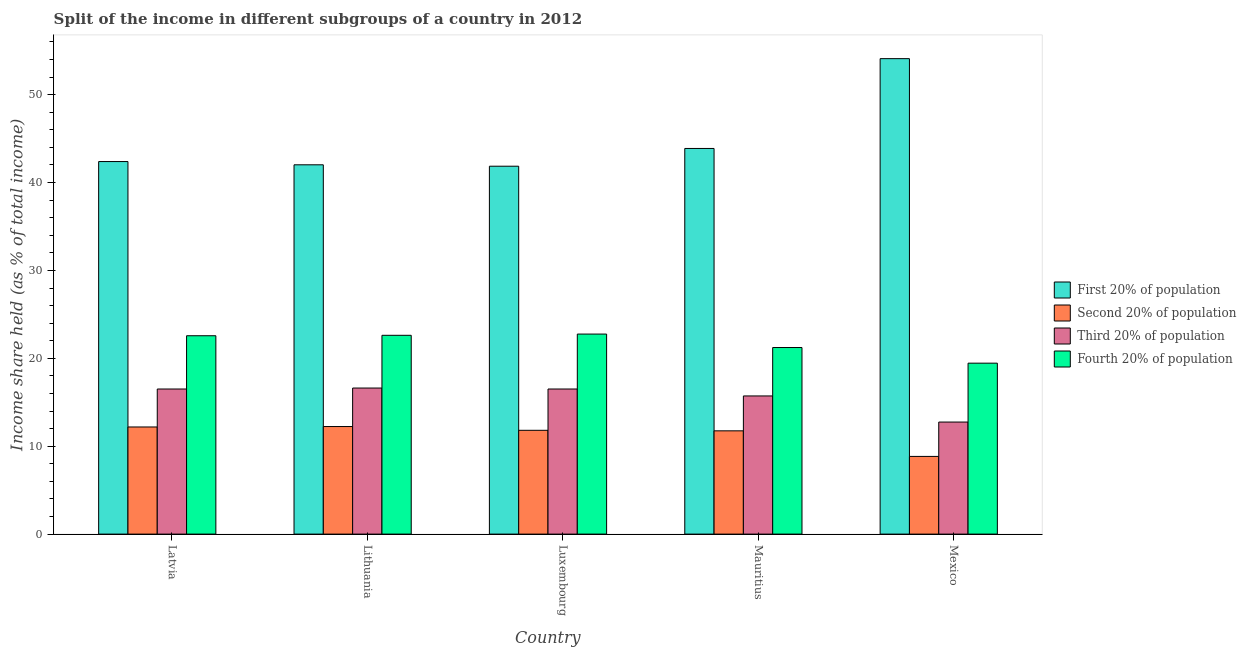How many groups of bars are there?
Ensure brevity in your answer.  5. Are the number of bars per tick equal to the number of legend labels?
Keep it short and to the point. Yes. What is the label of the 1st group of bars from the left?
Keep it short and to the point. Latvia. In how many cases, is the number of bars for a given country not equal to the number of legend labels?
Offer a very short reply. 0. What is the share of the income held by third 20% of the population in Latvia?
Keep it short and to the point. 16.51. Across all countries, what is the maximum share of the income held by third 20% of the population?
Your answer should be compact. 16.62. Across all countries, what is the minimum share of the income held by first 20% of the population?
Your answer should be very brief. 41.86. In which country was the share of the income held by third 20% of the population maximum?
Keep it short and to the point. Lithuania. In which country was the share of the income held by first 20% of the population minimum?
Provide a succinct answer. Luxembourg. What is the total share of the income held by fourth 20% of the population in the graph?
Offer a terse response. 108.63. What is the difference between the share of the income held by third 20% of the population in Mauritius and that in Mexico?
Give a very brief answer. 2.97. What is the difference between the share of the income held by first 20% of the population in Mexico and the share of the income held by second 20% of the population in Mauritius?
Ensure brevity in your answer.  42.35. What is the average share of the income held by fourth 20% of the population per country?
Ensure brevity in your answer.  21.73. What is the difference between the share of the income held by fourth 20% of the population and share of the income held by first 20% of the population in Mexico?
Your answer should be compact. -34.65. What is the ratio of the share of the income held by third 20% of the population in Lithuania to that in Luxembourg?
Ensure brevity in your answer.  1.01. Is the share of the income held by second 20% of the population in Latvia less than that in Mauritius?
Provide a short and direct response. No. What is the difference between the highest and the second highest share of the income held by third 20% of the population?
Your response must be concise. 0.11. What is the difference between the highest and the lowest share of the income held by third 20% of the population?
Provide a short and direct response. 3.87. Is the sum of the share of the income held by third 20% of the population in Mauritius and Mexico greater than the maximum share of the income held by fourth 20% of the population across all countries?
Offer a terse response. Yes. What does the 1st bar from the left in Mexico represents?
Provide a succinct answer. First 20% of population. What does the 4th bar from the right in Mexico represents?
Keep it short and to the point. First 20% of population. Is it the case that in every country, the sum of the share of the income held by first 20% of the population and share of the income held by second 20% of the population is greater than the share of the income held by third 20% of the population?
Ensure brevity in your answer.  Yes. How many countries are there in the graph?
Provide a short and direct response. 5. How many legend labels are there?
Provide a succinct answer. 4. What is the title of the graph?
Give a very brief answer. Split of the income in different subgroups of a country in 2012. Does "Other greenhouse gases" appear as one of the legend labels in the graph?
Make the answer very short. No. What is the label or title of the X-axis?
Offer a very short reply. Country. What is the label or title of the Y-axis?
Provide a succinct answer. Income share held (as % of total income). What is the Income share held (as % of total income) of First 20% of population in Latvia?
Offer a very short reply. 42.39. What is the Income share held (as % of total income) in Second 20% of population in Latvia?
Keep it short and to the point. 12.19. What is the Income share held (as % of total income) of Third 20% of population in Latvia?
Keep it short and to the point. 16.51. What is the Income share held (as % of total income) in Fourth 20% of population in Latvia?
Give a very brief answer. 22.57. What is the Income share held (as % of total income) of First 20% of population in Lithuania?
Your answer should be very brief. 42.02. What is the Income share held (as % of total income) in Second 20% of population in Lithuania?
Offer a terse response. 12.24. What is the Income share held (as % of total income) of Third 20% of population in Lithuania?
Provide a short and direct response. 16.62. What is the Income share held (as % of total income) of Fourth 20% of population in Lithuania?
Provide a short and direct response. 22.62. What is the Income share held (as % of total income) of First 20% of population in Luxembourg?
Offer a very short reply. 41.86. What is the Income share held (as % of total income) in Second 20% of population in Luxembourg?
Give a very brief answer. 11.81. What is the Income share held (as % of total income) of Third 20% of population in Luxembourg?
Your answer should be very brief. 16.51. What is the Income share held (as % of total income) of Fourth 20% of population in Luxembourg?
Ensure brevity in your answer.  22.76. What is the Income share held (as % of total income) in First 20% of population in Mauritius?
Ensure brevity in your answer.  43.88. What is the Income share held (as % of total income) of Second 20% of population in Mauritius?
Make the answer very short. 11.75. What is the Income share held (as % of total income) in Third 20% of population in Mauritius?
Keep it short and to the point. 15.72. What is the Income share held (as % of total income) of Fourth 20% of population in Mauritius?
Your answer should be compact. 21.23. What is the Income share held (as % of total income) of First 20% of population in Mexico?
Make the answer very short. 54.1. What is the Income share held (as % of total income) in Second 20% of population in Mexico?
Your answer should be compact. 8.84. What is the Income share held (as % of total income) in Third 20% of population in Mexico?
Ensure brevity in your answer.  12.75. What is the Income share held (as % of total income) in Fourth 20% of population in Mexico?
Offer a terse response. 19.45. Across all countries, what is the maximum Income share held (as % of total income) in First 20% of population?
Make the answer very short. 54.1. Across all countries, what is the maximum Income share held (as % of total income) in Second 20% of population?
Give a very brief answer. 12.24. Across all countries, what is the maximum Income share held (as % of total income) in Third 20% of population?
Provide a succinct answer. 16.62. Across all countries, what is the maximum Income share held (as % of total income) in Fourth 20% of population?
Provide a short and direct response. 22.76. Across all countries, what is the minimum Income share held (as % of total income) of First 20% of population?
Keep it short and to the point. 41.86. Across all countries, what is the minimum Income share held (as % of total income) in Second 20% of population?
Keep it short and to the point. 8.84. Across all countries, what is the minimum Income share held (as % of total income) of Third 20% of population?
Make the answer very short. 12.75. Across all countries, what is the minimum Income share held (as % of total income) in Fourth 20% of population?
Make the answer very short. 19.45. What is the total Income share held (as % of total income) in First 20% of population in the graph?
Keep it short and to the point. 224.25. What is the total Income share held (as % of total income) of Second 20% of population in the graph?
Offer a very short reply. 56.83. What is the total Income share held (as % of total income) of Third 20% of population in the graph?
Provide a short and direct response. 78.11. What is the total Income share held (as % of total income) in Fourth 20% of population in the graph?
Provide a succinct answer. 108.63. What is the difference between the Income share held (as % of total income) of First 20% of population in Latvia and that in Lithuania?
Offer a terse response. 0.37. What is the difference between the Income share held (as % of total income) of Third 20% of population in Latvia and that in Lithuania?
Offer a very short reply. -0.11. What is the difference between the Income share held (as % of total income) of First 20% of population in Latvia and that in Luxembourg?
Provide a succinct answer. 0.53. What is the difference between the Income share held (as % of total income) in Second 20% of population in Latvia and that in Luxembourg?
Your answer should be compact. 0.38. What is the difference between the Income share held (as % of total income) of Third 20% of population in Latvia and that in Luxembourg?
Ensure brevity in your answer.  0. What is the difference between the Income share held (as % of total income) in Fourth 20% of population in Latvia and that in Luxembourg?
Ensure brevity in your answer.  -0.19. What is the difference between the Income share held (as % of total income) in First 20% of population in Latvia and that in Mauritius?
Your answer should be compact. -1.49. What is the difference between the Income share held (as % of total income) in Second 20% of population in Latvia and that in Mauritius?
Give a very brief answer. 0.44. What is the difference between the Income share held (as % of total income) in Third 20% of population in Latvia and that in Mauritius?
Offer a very short reply. 0.79. What is the difference between the Income share held (as % of total income) of Fourth 20% of population in Latvia and that in Mauritius?
Your answer should be very brief. 1.34. What is the difference between the Income share held (as % of total income) in First 20% of population in Latvia and that in Mexico?
Your answer should be very brief. -11.71. What is the difference between the Income share held (as % of total income) in Second 20% of population in Latvia and that in Mexico?
Keep it short and to the point. 3.35. What is the difference between the Income share held (as % of total income) in Third 20% of population in Latvia and that in Mexico?
Ensure brevity in your answer.  3.76. What is the difference between the Income share held (as % of total income) of Fourth 20% of population in Latvia and that in Mexico?
Offer a terse response. 3.12. What is the difference between the Income share held (as % of total income) in First 20% of population in Lithuania and that in Luxembourg?
Your answer should be compact. 0.16. What is the difference between the Income share held (as % of total income) in Second 20% of population in Lithuania and that in Luxembourg?
Keep it short and to the point. 0.43. What is the difference between the Income share held (as % of total income) of Third 20% of population in Lithuania and that in Luxembourg?
Your response must be concise. 0.11. What is the difference between the Income share held (as % of total income) of Fourth 20% of population in Lithuania and that in Luxembourg?
Your response must be concise. -0.14. What is the difference between the Income share held (as % of total income) of First 20% of population in Lithuania and that in Mauritius?
Your response must be concise. -1.86. What is the difference between the Income share held (as % of total income) of Second 20% of population in Lithuania and that in Mauritius?
Ensure brevity in your answer.  0.49. What is the difference between the Income share held (as % of total income) in Fourth 20% of population in Lithuania and that in Mauritius?
Your answer should be very brief. 1.39. What is the difference between the Income share held (as % of total income) in First 20% of population in Lithuania and that in Mexico?
Provide a short and direct response. -12.08. What is the difference between the Income share held (as % of total income) of Third 20% of population in Lithuania and that in Mexico?
Your response must be concise. 3.87. What is the difference between the Income share held (as % of total income) of Fourth 20% of population in Lithuania and that in Mexico?
Your answer should be very brief. 3.17. What is the difference between the Income share held (as % of total income) in First 20% of population in Luxembourg and that in Mauritius?
Offer a terse response. -2.02. What is the difference between the Income share held (as % of total income) of Second 20% of population in Luxembourg and that in Mauritius?
Provide a short and direct response. 0.06. What is the difference between the Income share held (as % of total income) in Third 20% of population in Luxembourg and that in Mauritius?
Make the answer very short. 0.79. What is the difference between the Income share held (as % of total income) in Fourth 20% of population in Luxembourg and that in Mauritius?
Offer a very short reply. 1.53. What is the difference between the Income share held (as % of total income) of First 20% of population in Luxembourg and that in Mexico?
Provide a short and direct response. -12.24. What is the difference between the Income share held (as % of total income) in Second 20% of population in Luxembourg and that in Mexico?
Give a very brief answer. 2.97. What is the difference between the Income share held (as % of total income) of Third 20% of population in Luxembourg and that in Mexico?
Your answer should be compact. 3.76. What is the difference between the Income share held (as % of total income) of Fourth 20% of population in Luxembourg and that in Mexico?
Your response must be concise. 3.31. What is the difference between the Income share held (as % of total income) in First 20% of population in Mauritius and that in Mexico?
Provide a succinct answer. -10.22. What is the difference between the Income share held (as % of total income) of Second 20% of population in Mauritius and that in Mexico?
Offer a very short reply. 2.91. What is the difference between the Income share held (as % of total income) in Third 20% of population in Mauritius and that in Mexico?
Provide a succinct answer. 2.97. What is the difference between the Income share held (as % of total income) of Fourth 20% of population in Mauritius and that in Mexico?
Ensure brevity in your answer.  1.78. What is the difference between the Income share held (as % of total income) of First 20% of population in Latvia and the Income share held (as % of total income) of Second 20% of population in Lithuania?
Provide a short and direct response. 30.15. What is the difference between the Income share held (as % of total income) of First 20% of population in Latvia and the Income share held (as % of total income) of Third 20% of population in Lithuania?
Make the answer very short. 25.77. What is the difference between the Income share held (as % of total income) in First 20% of population in Latvia and the Income share held (as % of total income) in Fourth 20% of population in Lithuania?
Give a very brief answer. 19.77. What is the difference between the Income share held (as % of total income) of Second 20% of population in Latvia and the Income share held (as % of total income) of Third 20% of population in Lithuania?
Give a very brief answer. -4.43. What is the difference between the Income share held (as % of total income) of Second 20% of population in Latvia and the Income share held (as % of total income) of Fourth 20% of population in Lithuania?
Give a very brief answer. -10.43. What is the difference between the Income share held (as % of total income) of Third 20% of population in Latvia and the Income share held (as % of total income) of Fourth 20% of population in Lithuania?
Offer a terse response. -6.11. What is the difference between the Income share held (as % of total income) of First 20% of population in Latvia and the Income share held (as % of total income) of Second 20% of population in Luxembourg?
Provide a succinct answer. 30.58. What is the difference between the Income share held (as % of total income) of First 20% of population in Latvia and the Income share held (as % of total income) of Third 20% of population in Luxembourg?
Your answer should be compact. 25.88. What is the difference between the Income share held (as % of total income) in First 20% of population in Latvia and the Income share held (as % of total income) in Fourth 20% of population in Luxembourg?
Your response must be concise. 19.63. What is the difference between the Income share held (as % of total income) in Second 20% of population in Latvia and the Income share held (as % of total income) in Third 20% of population in Luxembourg?
Your answer should be compact. -4.32. What is the difference between the Income share held (as % of total income) in Second 20% of population in Latvia and the Income share held (as % of total income) in Fourth 20% of population in Luxembourg?
Provide a succinct answer. -10.57. What is the difference between the Income share held (as % of total income) in Third 20% of population in Latvia and the Income share held (as % of total income) in Fourth 20% of population in Luxembourg?
Your answer should be compact. -6.25. What is the difference between the Income share held (as % of total income) of First 20% of population in Latvia and the Income share held (as % of total income) of Second 20% of population in Mauritius?
Your answer should be compact. 30.64. What is the difference between the Income share held (as % of total income) of First 20% of population in Latvia and the Income share held (as % of total income) of Third 20% of population in Mauritius?
Your answer should be very brief. 26.67. What is the difference between the Income share held (as % of total income) of First 20% of population in Latvia and the Income share held (as % of total income) of Fourth 20% of population in Mauritius?
Give a very brief answer. 21.16. What is the difference between the Income share held (as % of total income) in Second 20% of population in Latvia and the Income share held (as % of total income) in Third 20% of population in Mauritius?
Offer a very short reply. -3.53. What is the difference between the Income share held (as % of total income) of Second 20% of population in Latvia and the Income share held (as % of total income) of Fourth 20% of population in Mauritius?
Ensure brevity in your answer.  -9.04. What is the difference between the Income share held (as % of total income) in Third 20% of population in Latvia and the Income share held (as % of total income) in Fourth 20% of population in Mauritius?
Give a very brief answer. -4.72. What is the difference between the Income share held (as % of total income) of First 20% of population in Latvia and the Income share held (as % of total income) of Second 20% of population in Mexico?
Offer a terse response. 33.55. What is the difference between the Income share held (as % of total income) of First 20% of population in Latvia and the Income share held (as % of total income) of Third 20% of population in Mexico?
Make the answer very short. 29.64. What is the difference between the Income share held (as % of total income) of First 20% of population in Latvia and the Income share held (as % of total income) of Fourth 20% of population in Mexico?
Your answer should be compact. 22.94. What is the difference between the Income share held (as % of total income) of Second 20% of population in Latvia and the Income share held (as % of total income) of Third 20% of population in Mexico?
Your answer should be very brief. -0.56. What is the difference between the Income share held (as % of total income) in Second 20% of population in Latvia and the Income share held (as % of total income) in Fourth 20% of population in Mexico?
Keep it short and to the point. -7.26. What is the difference between the Income share held (as % of total income) of Third 20% of population in Latvia and the Income share held (as % of total income) of Fourth 20% of population in Mexico?
Your answer should be very brief. -2.94. What is the difference between the Income share held (as % of total income) in First 20% of population in Lithuania and the Income share held (as % of total income) in Second 20% of population in Luxembourg?
Make the answer very short. 30.21. What is the difference between the Income share held (as % of total income) of First 20% of population in Lithuania and the Income share held (as % of total income) of Third 20% of population in Luxembourg?
Offer a very short reply. 25.51. What is the difference between the Income share held (as % of total income) of First 20% of population in Lithuania and the Income share held (as % of total income) of Fourth 20% of population in Luxembourg?
Offer a terse response. 19.26. What is the difference between the Income share held (as % of total income) of Second 20% of population in Lithuania and the Income share held (as % of total income) of Third 20% of population in Luxembourg?
Provide a succinct answer. -4.27. What is the difference between the Income share held (as % of total income) of Second 20% of population in Lithuania and the Income share held (as % of total income) of Fourth 20% of population in Luxembourg?
Keep it short and to the point. -10.52. What is the difference between the Income share held (as % of total income) in Third 20% of population in Lithuania and the Income share held (as % of total income) in Fourth 20% of population in Luxembourg?
Your answer should be compact. -6.14. What is the difference between the Income share held (as % of total income) in First 20% of population in Lithuania and the Income share held (as % of total income) in Second 20% of population in Mauritius?
Provide a short and direct response. 30.27. What is the difference between the Income share held (as % of total income) of First 20% of population in Lithuania and the Income share held (as % of total income) of Third 20% of population in Mauritius?
Ensure brevity in your answer.  26.3. What is the difference between the Income share held (as % of total income) in First 20% of population in Lithuania and the Income share held (as % of total income) in Fourth 20% of population in Mauritius?
Provide a succinct answer. 20.79. What is the difference between the Income share held (as % of total income) in Second 20% of population in Lithuania and the Income share held (as % of total income) in Third 20% of population in Mauritius?
Your answer should be very brief. -3.48. What is the difference between the Income share held (as % of total income) of Second 20% of population in Lithuania and the Income share held (as % of total income) of Fourth 20% of population in Mauritius?
Provide a succinct answer. -8.99. What is the difference between the Income share held (as % of total income) in Third 20% of population in Lithuania and the Income share held (as % of total income) in Fourth 20% of population in Mauritius?
Your response must be concise. -4.61. What is the difference between the Income share held (as % of total income) in First 20% of population in Lithuania and the Income share held (as % of total income) in Second 20% of population in Mexico?
Your response must be concise. 33.18. What is the difference between the Income share held (as % of total income) of First 20% of population in Lithuania and the Income share held (as % of total income) of Third 20% of population in Mexico?
Offer a very short reply. 29.27. What is the difference between the Income share held (as % of total income) in First 20% of population in Lithuania and the Income share held (as % of total income) in Fourth 20% of population in Mexico?
Provide a succinct answer. 22.57. What is the difference between the Income share held (as % of total income) of Second 20% of population in Lithuania and the Income share held (as % of total income) of Third 20% of population in Mexico?
Your response must be concise. -0.51. What is the difference between the Income share held (as % of total income) of Second 20% of population in Lithuania and the Income share held (as % of total income) of Fourth 20% of population in Mexico?
Keep it short and to the point. -7.21. What is the difference between the Income share held (as % of total income) of Third 20% of population in Lithuania and the Income share held (as % of total income) of Fourth 20% of population in Mexico?
Ensure brevity in your answer.  -2.83. What is the difference between the Income share held (as % of total income) in First 20% of population in Luxembourg and the Income share held (as % of total income) in Second 20% of population in Mauritius?
Ensure brevity in your answer.  30.11. What is the difference between the Income share held (as % of total income) of First 20% of population in Luxembourg and the Income share held (as % of total income) of Third 20% of population in Mauritius?
Provide a succinct answer. 26.14. What is the difference between the Income share held (as % of total income) of First 20% of population in Luxembourg and the Income share held (as % of total income) of Fourth 20% of population in Mauritius?
Provide a short and direct response. 20.63. What is the difference between the Income share held (as % of total income) of Second 20% of population in Luxembourg and the Income share held (as % of total income) of Third 20% of population in Mauritius?
Provide a succinct answer. -3.91. What is the difference between the Income share held (as % of total income) in Second 20% of population in Luxembourg and the Income share held (as % of total income) in Fourth 20% of population in Mauritius?
Offer a terse response. -9.42. What is the difference between the Income share held (as % of total income) in Third 20% of population in Luxembourg and the Income share held (as % of total income) in Fourth 20% of population in Mauritius?
Make the answer very short. -4.72. What is the difference between the Income share held (as % of total income) of First 20% of population in Luxembourg and the Income share held (as % of total income) of Second 20% of population in Mexico?
Keep it short and to the point. 33.02. What is the difference between the Income share held (as % of total income) in First 20% of population in Luxembourg and the Income share held (as % of total income) in Third 20% of population in Mexico?
Make the answer very short. 29.11. What is the difference between the Income share held (as % of total income) of First 20% of population in Luxembourg and the Income share held (as % of total income) of Fourth 20% of population in Mexico?
Keep it short and to the point. 22.41. What is the difference between the Income share held (as % of total income) in Second 20% of population in Luxembourg and the Income share held (as % of total income) in Third 20% of population in Mexico?
Keep it short and to the point. -0.94. What is the difference between the Income share held (as % of total income) in Second 20% of population in Luxembourg and the Income share held (as % of total income) in Fourth 20% of population in Mexico?
Your answer should be very brief. -7.64. What is the difference between the Income share held (as % of total income) of Third 20% of population in Luxembourg and the Income share held (as % of total income) of Fourth 20% of population in Mexico?
Offer a terse response. -2.94. What is the difference between the Income share held (as % of total income) of First 20% of population in Mauritius and the Income share held (as % of total income) of Second 20% of population in Mexico?
Offer a terse response. 35.04. What is the difference between the Income share held (as % of total income) of First 20% of population in Mauritius and the Income share held (as % of total income) of Third 20% of population in Mexico?
Make the answer very short. 31.13. What is the difference between the Income share held (as % of total income) in First 20% of population in Mauritius and the Income share held (as % of total income) in Fourth 20% of population in Mexico?
Offer a terse response. 24.43. What is the difference between the Income share held (as % of total income) of Second 20% of population in Mauritius and the Income share held (as % of total income) of Third 20% of population in Mexico?
Your response must be concise. -1. What is the difference between the Income share held (as % of total income) of Second 20% of population in Mauritius and the Income share held (as % of total income) of Fourth 20% of population in Mexico?
Provide a succinct answer. -7.7. What is the difference between the Income share held (as % of total income) in Third 20% of population in Mauritius and the Income share held (as % of total income) in Fourth 20% of population in Mexico?
Provide a short and direct response. -3.73. What is the average Income share held (as % of total income) of First 20% of population per country?
Ensure brevity in your answer.  44.85. What is the average Income share held (as % of total income) of Second 20% of population per country?
Your response must be concise. 11.37. What is the average Income share held (as % of total income) of Third 20% of population per country?
Provide a succinct answer. 15.62. What is the average Income share held (as % of total income) in Fourth 20% of population per country?
Offer a terse response. 21.73. What is the difference between the Income share held (as % of total income) of First 20% of population and Income share held (as % of total income) of Second 20% of population in Latvia?
Make the answer very short. 30.2. What is the difference between the Income share held (as % of total income) in First 20% of population and Income share held (as % of total income) in Third 20% of population in Latvia?
Offer a terse response. 25.88. What is the difference between the Income share held (as % of total income) in First 20% of population and Income share held (as % of total income) in Fourth 20% of population in Latvia?
Provide a succinct answer. 19.82. What is the difference between the Income share held (as % of total income) in Second 20% of population and Income share held (as % of total income) in Third 20% of population in Latvia?
Make the answer very short. -4.32. What is the difference between the Income share held (as % of total income) in Second 20% of population and Income share held (as % of total income) in Fourth 20% of population in Latvia?
Ensure brevity in your answer.  -10.38. What is the difference between the Income share held (as % of total income) in Third 20% of population and Income share held (as % of total income) in Fourth 20% of population in Latvia?
Make the answer very short. -6.06. What is the difference between the Income share held (as % of total income) in First 20% of population and Income share held (as % of total income) in Second 20% of population in Lithuania?
Ensure brevity in your answer.  29.78. What is the difference between the Income share held (as % of total income) in First 20% of population and Income share held (as % of total income) in Third 20% of population in Lithuania?
Your response must be concise. 25.4. What is the difference between the Income share held (as % of total income) in Second 20% of population and Income share held (as % of total income) in Third 20% of population in Lithuania?
Your answer should be compact. -4.38. What is the difference between the Income share held (as % of total income) of Second 20% of population and Income share held (as % of total income) of Fourth 20% of population in Lithuania?
Make the answer very short. -10.38. What is the difference between the Income share held (as % of total income) in First 20% of population and Income share held (as % of total income) in Second 20% of population in Luxembourg?
Your answer should be very brief. 30.05. What is the difference between the Income share held (as % of total income) of First 20% of population and Income share held (as % of total income) of Third 20% of population in Luxembourg?
Make the answer very short. 25.35. What is the difference between the Income share held (as % of total income) of Second 20% of population and Income share held (as % of total income) of Third 20% of population in Luxembourg?
Keep it short and to the point. -4.7. What is the difference between the Income share held (as % of total income) of Second 20% of population and Income share held (as % of total income) of Fourth 20% of population in Luxembourg?
Offer a very short reply. -10.95. What is the difference between the Income share held (as % of total income) in Third 20% of population and Income share held (as % of total income) in Fourth 20% of population in Luxembourg?
Give a very brief answer. -6.25. What is the difference between the Income share held (as % of total income) of First 20% of population and Income share held (as % of total income) of Second 20% of population in Mauritius?
Provide a short and direct response. 32.13. What is the difference between the Income share held (as % of total income) in First 20% of population and Income share held (as % of total income) in Third 20% of population in Mauritius?
Offer a very short reply. 28.16. What is the difference between the Income share held (as % of total income) of First 20% of population and Income share held (as % of total income) of Fourth 20% of population in Mauritius?
Offer a very short reply. 22.65. What is the difference between the Income share held (as % of total income) in Second 20% of population and Income share held (as % of total income) in Third 20% of population in Mauritius?
Make the answer very short. -3.97. What is the difference between the Income share held (as % of total income) of Second 20% of population and Income share held (as % of total income) of Fourth 20% of population in Mauritius?
Your response must be concise. -9.48. What is the difference between the Income share held (as % of total income) of Third 20% of population and Income share held (as % of total income) of Fourth 20% of population in Mauritius?
Your answer should be very brief. -5.51. What is the difference between the Income share held (as % of total income) in First 20% of population and Income share held (as % of total income) in Second 20% of population in Mexico?
Provide a short and direct response. 45.26. What is the difference between the Income share held (as % of total income) in First 20% of population and Income share held (as % of total income) in Third 20% of population in Mexico?
Offer a terse response. 41.35. What is the difference between the Income share held (as % of total income) of First 20% of population and Income share held (as % of total income) of Fourth 20% of population in Mexico?
Your response must be concise. 34.65. What is the difference between the Income share held (as % of total income) of Second 20% of population and Income share held (as % of total income) of Third 20% of population in Mexico?
Give a very brief answer. -3.91. What is the difference between the Income share held (as % of total income) in Second 20% of population and Income share held (as % of total income) in Fourth 20% of population in Mexico?
Provide a succinct answer. -10.61. What is the difference between the Income share held (as % of total income) of Third 20% of population and Income share held (as % of total income) of Fourth 20% of population in Mexico?
Provide a short and direct response. -6.7. What is the ratio of the Income share held (as % of total income) of First 20% of population in Latvia to that in Lithuania?
Keep it short and to the point. 1.01. What is the ratio of the Income share held (as % of total income) in Second 20% of population in Latvia to that in Lithuania?
Give a very brief answer. 1. What is the ratio of the Income share held (as % of total income) in Fourth 20% of population in Latvia to that in Lithuania?
Keep it short and to the point. 1. What is the ratio of the Income share held (as % of total income) of First 20% of population in Latvia to that in Luxembourg?
Provide a short and direct response. 1.01. What is the ratio of the Income share held (as % of total income) in Second 20% of population in Latvia to that in Luxembourg?
Provide a short and direct response. 1.03. What is the ratio of the Income share held (as % of total income) in Third 20% of population in Latvia to that in Luxembourg?
Keep it short and to the point. 1. What is the ratio of the Income share held (as % of total income) in First 20% of population in Latvia to that in Mauritius?
Your answer should be very brief. 0.97. What is the ratio of the Income share held (as % of total income) of Second 20% of population in Latvia to that in Mauritius?
Your answer should be compact. 1.04. What is the ratio of the Income share held (as % of total income) in Third 20% of population in Latvia to that in Mauritius?
Your answer should be very brief. 1.05. What is the ratio of the Income share held (as % of total income) of Fourth 20% of population in Latvia to that in Mauritius?
Your response must be concise. 1.06. What is the ratio of the Income share held (as % of total income) of First 20% of population in Latvia to that in Mexico?
Your response must be concise. 0.78. What is the ratio of the Income share held (as % of total income) of Second 20% of population in Latvia to that in Mexico?
Your answer should be very brief. 1.38. What is the ratio of the Income share held (as % of total income) of Third 20% of population in Latvia to that in Mexico?
Offer a very short reply. 1.29. What is the ratio of the Income share held (as % of total income) of Fourth 20% of population in Latvia to that in Mexico?
Provide a short and direct response. 1.16. What is the ratio of the Income share held (as % of total income) in Second 20% of population in Lithuania to that in Luxembourg?
Keep it short and to the point. 1.04. What is the ratio of the Income share held (as % of total income) of Fourth 20% of population in Lithuania to that in Luxembourg?
Provide a succinct answer. 0.99. What is the ratio of the Income share held (as % of total income) of First 20% of population in Lithuania to that in Mauritius?
Your answer should be compact. 0.96. What is the ratio of the Income share held (as % of total income) of Second 20% of population in Lithuania to that in Mauritius?
Provide a short and direct response. 1.04. What is the ratio of the Income share held (as % of total income) of Third 20% of population in Lithuania to that in Mauritius?
Keep it short and to the point. 1.06. What is the ratio of the Income share held (as % of total income) in Fourth 20% of population in Lithuania to that in Mauritius?
Offer a terse response. 1.07. What is the ratio of the Income share held (as % of total income) of First 20% of population in Lithuania to that in Mexico?
Provide a short and direct response. 0.78. What is the ratio of the Income share held (as % of total income) in Second 20% of population in Lithuania to that in Mexico?
Your response must be concise. 1.38. What is the ratio of the Income share held (as % of total income) in Third 20% of population in Lithuania to that in Mexico?
Offer a very short reply. 1.3. What is the ratio of the Income share held (as % of total income) of Fourth 20% of population in Lithuania to that in Mexico?
Your answer should be very brief. 1.16. What is the ratio of the Income share held (as % of total income) in First 20% of population in Luxembourg to that in Mauritius?
Your answer should be very brief. 0.95. What is the ratio of the Income share held (as % of total income) in Third 20% of population in Luxembourg to that in Mauritius?
Your answer should be compact. 1.05. What is the ratio of the Income share held (as % of total income) in Fourth 20% of population in Luxembourg to that in Mauritius?
Your answer should be compact. 1.07. What is the ratio of the Income share held (as % of total income) of First 20% of population in Luxembourg to that in Mexico?
Your answer should be very brief. 0.77. What is the ratio of the Income share held (as % of total income) of Second 20% of population in Luxembourg to that in Mexico?
Offer a terse response. 1.34. What is the ratio of the Income share held (as % of total income) of Third 20% of population in Luxembourg to that in Mexico?
Provide a short and direct response. 1.29. What is the ratio of the Income share held (as % of total income) of Fourth 20% of population in Luxembourg to that in Mexico?
Provide a succinct answer. 1.17. What is the ratio of the Income share held (as % of total income) of First 20% of population in Mauritius to that in Mexico?
Your response must be concise. 0.81. What is the ratio of the Income share held (as % of total income) in Second 20% of population in Mauritius to that in Mexico?
Ensure brevity in your answer.  1.33. What is the ratio of the Income share held (as % of total income) in Third 20% of population in Mauritius to that in Mexico?
Offer a terse response. 1.23. What is the ratio of the Income share held (as % of total income) in Fourth 20% of population in Mauritius to that in Mexico?
Give a very brief answer. 1.09. What is the difference between the highest and the second highest Income share held (as % of total income) in First 20% of population?
Provide a short and direct response. 10.22. What is the difference between the highest and the second highest Income share held (as % of total income) in Second 20% of population?
Give a very brief answer. 0.05. What is the difference between the highest and the second highest Income share held (as % of total income) in Third 20% of population?
Offer a terse response. 0.11. What is the difference between the highest and the second highest Income share held (as % of total income) in Fourth 20% of population?
Make the answer very short. 0.14. What is the difference between the highest and the lowest Income share held (as % of total income) in First 20% of population?
Your answer should be very brief. 12.24. What is the difference between the highest and the lowest Income share held (as % of total income) in Third 20% of population?
Provide a succinct answer. 3.87. What is the difference between the highest and the lowest Income share held (as % of total income) of Fourth 20% of population?
Make the answer very short. 3.31. 